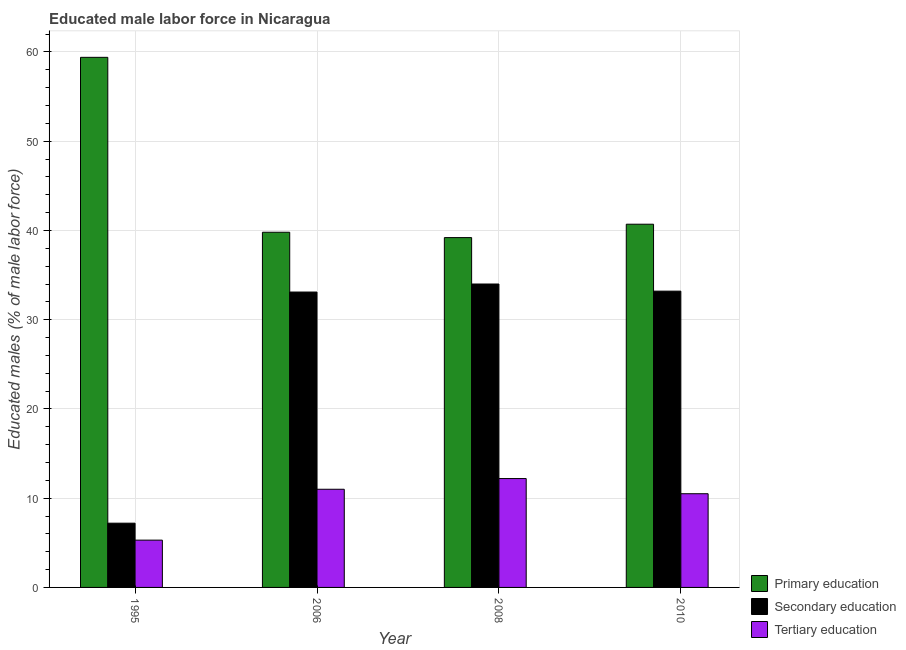How many groups of bars are there?
Offer a very short reply. 4. Are the number of bars per tick equal to the number of legend labels?
Offer a terse response. Yes. How many bars are there on the 4th tick from the left?
Offer a terse response. 3. How many bars are there on the 3rd tick from the right?
Offer a very short reply. 3. What is the label of the 3rd group of bars from the left?
Your answer should be very brief. 2008. In how many cases, is the number of bars for a given year not equal to the number of legend labels?
Keep it short and to the point. 0. What is the percentage of male labor force who received secondary education in 2006?
Your answer should be compact. 33.1. Across all years, what is the maximum percentage of male labor force who received tertiary education?
Provide a succinct answer. 12.2. Across all years, what is the minimum percentage of male labor force who received secondary education?
Ensure brevity in your answer.  7.2. What is the total percentage of male labor force who received secondary education in the graph?
Keep it short and to the point. 107.5. What is the difference between the percentage of male labor force who received primary education in 1995 and that in 2010?
Keep it short and to the point. 18.7. What is the difference between the percentage of male labor force who received primary education in 2008 and the percentage of male labor force who received tertiary education in 1995?
Ensure brevity in your answer.  -20.2. What is the average percentage of male labor force who received primary education per year?
Keep it short and to the point. 44.78. In the year 1995, what is the difference between the percentage of male labor force who received tertiary education and percentage of male labor force who received primary education?
Keep it short and to the point. 0. In how many years, is the percentage of male labor force who received tertiary education greater than 26 %?
Provide a succinct answer. 0. What is the ratio of the percentage of male labor force who received tertiary education in 2006 to that in 2010?
Offer a terse response. 1.05. What is the difference between the highest and the second highest percentage of male labor force who received tertiary education?
Your answer should be compact. 1.2. What is the difference between the highest and the lowest percentage of male labor force who received secondary education?
Offer a terse response. 26.8. In how many years, is the percentage of male labor force who received primary education greater than the average percentage of male labor force who received primary education taken over all years?
Keep it short and to the point. 1. Is it the case that in every year, the sum of the percentage of male labor force who received primary education and percentage of male labor force who received secondary education is greater than the percentage of male labor force who received tertiary education?
Give a very brief answer. Yes. How many years are there in the graph?
Keep it short and to the point. 4. What is the difference between two consecutive major ticks on the Y-axis?
Offer a very short reply. 10. Does the graph contain grids?
Your answer should be very brief. Yes. Where does the legend appear in the graph?
Your response must be concise. Bottom right. How many legend labels are there?
Keep it short and to the point. 3. How are the legend labels stacked?
Make the answer very short. Vertical. What is the title of the graph?
Ensure brevity in your answer.  Educated male labor force in Nicaragua. Does "Domestic" appear as one of the legend labels in the graph?
Keep it short and to the point. No. What is the label or title of the X-axis?
Your answer should be very brief. Year. What is the label or title of the Y-axis?
Your answer should be compact. Educated males (% of male labor force). What is the Educated males (% of male labor force) in Primary education in 1995?
Your answer should be compact. 59.4. What is the Educated males (% of male labor force) in Secondary education in 1995?
Provide a succinct answer. 7.2. What is the Educated males (% of male labor force) of Tertiary education in 1995?
Your response must be concise. 5.3. What is the Educated males (% of male labor force) of Primary education in 2006?
Your answer should be compact. 39.8. What is the Educated males (% of male labor force) in Secondary education in 2006?
Offer a terse response. 33.1. What is the Educated males (% of male labor force) in Tertiary education in 2006?
Your response must be concise. 11. What is the Educated males (% of male labor force) of Primary education in 2008?
Offer a terse response. 39.2. What is the Educated males (% of male labor force) in Secondary education in 2008?
Make the answer very short. 34. What is the Educated males (% of male labor force) in Tertiary education in 2008?
Give a very brief answer. 12.2. What is the Educated males (% of male labor force) in Primary education in 2010?
Your answer should be compact. 40.7. What is the Educated males (% of male labor force) in Secondary education in 2010?
Give a very brief answer. 33.2. Across all years, what is the maximum Educated males (% of male labor force) of Primary education?
Offer a terse response. 59.4. Across all years, what is the maximum Educated males (% of male labor force) of Tertiary education?
Provide a short and direct response. 12.2. Across all years, what is the minimum Educated males (% of male labor force) in Primary education?
Your answer should be very brief. 39.2. Across all years, what is the minimum Educated males (% of male labor force) of Secondary education?
Offer a very short reply. 7.2. Across all years, what is the minimum Educated males (% of male labor force) of Tertiary education?
Provide a succinct answer. 5.3. What is the total Educated males (% of male labor force) in Primary education in the graph?
Your answer should be compact. 179.1. What is the total Educated males (% of male labor force) of Secondary education in the graph?
Offer a very short reply. 107.5. What is the difference between the Educated males (% of male labor force) in Primary education in 1995 and that in 2006?
Ensure brevity in your answer.  19.6. What is the difference between the Educated males (% of male labor force) in Secondary education in 1995 and that in 2006?
Offer a very short reply. -25.9. What is the difference between the Educated males (% of male labor force) in Tertiary education in 1995 and that in 2006?
Offer a terse response. -5.7. What is the difference between the Educated males (% of male labor force) of Primary education in 1995 and that in 2008?
Keep it short and to the point. 20.2. What is the difference between the Educated males (% of male labor force) in Secondary education in 1995 and that in 2008?
Offer a very short reply. -26.8. What is the difference between the Educated males (% of male labor force) of Primary education in 1995 and that in 2010?
Give a very brief answer. 18.7. What is the difference between the Educated males (% of male labor force) in Secondary education in 1995 and that in 2010?
Keep it short and to the point. -26. What is the difference between the Educated males (% of male labor force) in Tertiary education in 2006 and that in 2008?
Give a very brief answer. -1.2. What is the difference between the Educated males (% of male labor force) in Secondary education in 2008 and that in 2010?
Provide a short and direct response. 0.8. What is the difference between the Educated males (% of male labor force) in Tertiary education in 2008 and that in 2010?
Your answer should be very brief. 1.7. What is the difference between the Educated males (% of male labor force) in Primary education in 1995 and the Educated males (% of male labor force) in Secondary education in 2006?
Provide a short and direct response. 26.3. What is the difference between the Educated males (% of male labor force) of Primary education in 1995 and the Educated males (% of male labor force) of Tertiary education in 2006?
Your answer should be very brief. 48.4. What is the difference between the Educated males (% of male labor force) of Primary education in 1995 and the Educated males (% of male labor force) of Secondary education in 2008?
Provide a succinct answer. 25.4. What is the difference between the Educated males (% of male labor force) of Primary education in 1995 and the Educated males (% of male labor force) of Tertiary education in 2008?
Offer a terse response. 47.2. What is the difference between the Educated males (% of male labor force) in Secondary education in 1995 and the Educated males (% of male labor force) in Tertiary education in 2008?
Your response must be concise. -5. What is the difference between the Educated males (% of male labor force) in Primary education in 1995 and the Educated males (% of male labor force) in Secondary education in 2010?
Provide a succinct answer. 26.2. What is the difference between the Educated males (% of male labor force) of Primary education in 1995 and the Educated males (% of male labor force) of Tertiary education in 2010?
Give a very brief answer. 48.9. What is the difference between the Educated males (% of male labor force) of Primary education in 2006 and the Educated males (% of male labor force) of Tertiary education in 2008?
Provide a succinct answer. 27.6. What is the difference between the Educated males (% of male labor force) of Secondary education in 2006 and the Educated males (% of male labor force) of Tertiary education in 2008?
Your answer should be compact. 20.9. What is the difference between the Educated males (% of male labor force) of Primary education in 2006 and the Educated males (% of male labor force) of Tertiary education in 2010?
Give a very brief answer. 29.3. What is the difference between the Educated males (% of male labor force) in Secondary education in 2006 and the Educated males (% of male labor force) in Tertiary education in 2010?
Provide a short and direct response. 22.6. What is the difference between the Educated males (% of male labor force) in Primary education in 2008 and the Educated males (% of male labor force) in Secondary education in 2010?
Make the answer very short. 6. What is the difference between the Educated males (% of male labor force) of Primary education in 2008 and the Educated males (% of male labor force) of Tertiary education in 2010?
Make the answer very short. 28.7. What is the average Educated males (% of male labor force) of Primary education per year?
Your answer should be compact. 44.77. What is the average Educated males (% of male labor force) in Secondary education per year?
Your answer should be compact. 26.88. What is the average Educated males (% of male labor force) of Tertiary education per year?
Ensure brevity in your answer.  9.75. In the year 1995, what is the difference between the Educated males (% of male labor force) in Primary education and Educated males (% of male labor force) in Secondary education?
Keep it short and to the point. 52.2. In the year 1995, what is the difference between the Educated males (% of male labor force) of Primary education and Educated males (% of male labor force) of Tertiary education?
Offer a terse response. 54.1. In the year 2006, what is the difference between the Educated males (% of male labor force) of Primary education and Educated males (% of male labor force) of Secondary education?
Offer a terse response. 6.7. In the year 2006, what is the difference between the Educated males (% of male labor force) in Primary education and Educated males (% of male labor force) in Tertiary education?
Your answer should be compact. 28.8. In the year 2006, what is the difference between the Educated males (% of male labor force) of Secondary education and Educated males (% of male labor force) of Tertiary education?
Keep it short and to the point. 22.1. In the year 2008, what is the difference between the Educated males (% of male labor force) in Secondary education and Educated males (% of male labor force) in Tertiary education?
Give a very brief answer. 21.8. In the year 2010, what is the difference between the Educated males (% of male labor force) in Primary education and Educated males (% of male labor force) in Tertiary education?
Offer a very short reply. 30.2. In the year 2010, what is the difference between the Educated males (% of male labor force) of Secondary education and Educated males (% of male labor force) of Tertiary education?
Provide a short and direct response. 22.7. What is the ratio of the Educated males (% of male labor force) of Primary education in 1995 to that in 2006?
Keep it short and to the point. 1.49. What is the ratio of the Educated males (% of male labor force) of Secondary education in 1995 to that in 2006?
Provide a succinct answer. 0.22. What is the ratio of the Educated males (% of male labor force) of Tertiary education in 1995 to that in 2006?
Your response must be concise. 0.48. What is the ratio of the Educated males (% of male labor force) of Primary education in 1995 to that in 2008?
Provide a short and direct response. 1.52. What is the ratio of the Educated males (% of male labor force) in Secondary education in 1995 to that in 2008?
Make the answer very short. 0.21. What is the ratio of the Educated males (% of male labor force) in Tertiary education in 1995 to that in 2008?
Your answer should be compact. 0.43. What is the ratio of the Educated males (% of male labor force) of Primary education in 1995 to that in 2010?
Offer a terse response. 1.46. What is the ratio of the Educated males (% of male labor force) of Secondary education in 1995 to that in 2010?
Ensure brevity in your answer.  0.22. What is the ratio of the Educated males (% of male labor force) in Tertiary education in 1995 to that in 2010?
Your answer should be compact. 0.5. What is the ratio of the Educated males (% of male labor force) in Primary education in 2006 to that in 2008?
Your answer should be compact. 1.02. What is the ratio of the Educated males (% of male labor force) in Secondary education in 2006 to that in 2008?
Offer a terse response. 0.97. What is the ratio of the Educated males (% of male labor force) in Tertiary education in 2006 to that in 2008?
Keep it short and to the point. 0.9. What is the ratio of the Educated males (% of male labor force) in Primary education in 2006 to that in 2010?
Your answer should be very brief. 0.98. What is the ratio of the Educated males (% of male labor force) in Secondary education in 2006 to that in 2010?
Offer a terse response. 1. What is the ratio of the Educated males (% of male labor force) of Tertiary education in 2006 to that in 2010?
Offer a terse response. 1.05. What is the ratio of the Educated males (% of male labor force) in Primary education in 2008 to that in 2010?
Give a very brief answer. 0.96. What is the ratio of the Educated males (% of male labor force) of Secondary education in 2008 to that in 2010?
Offer a terse response. 1.02. What is the ratio of the Educated males (% of male labor force) in Tertiary education in 2008 to that in 2010?
Provide a succinct answer. 1.16. What is the difference between the highest and the lowest Educated males (% of male labor force) in Primary education?
Offer a very short reply. 20.2. What is the difference between the highest and the lowest Educated males (% of male labor force) in Secondary education?
Make the answer very short. 26.8. What is the difference between the highest and the lowest Educated males (% of male labor force) in Tertiary education?
Provide a succinct answer. 6.9. 